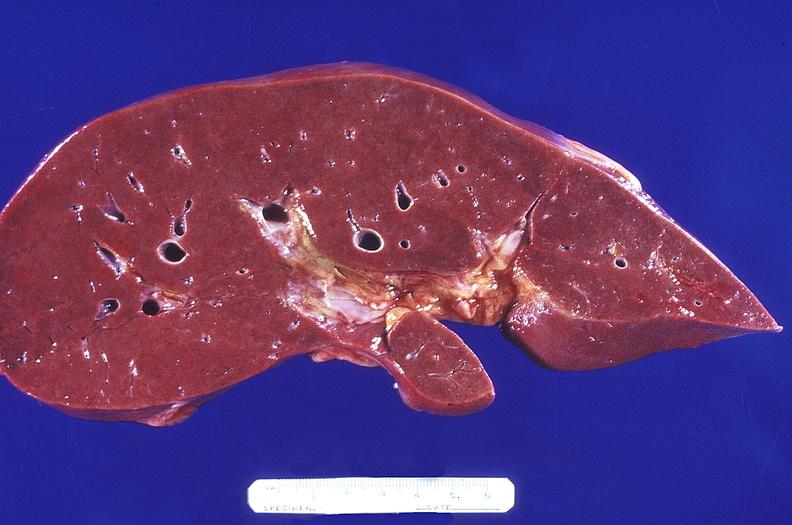what does this image show?
Answer the question using a single word or phrase. Normal liver 